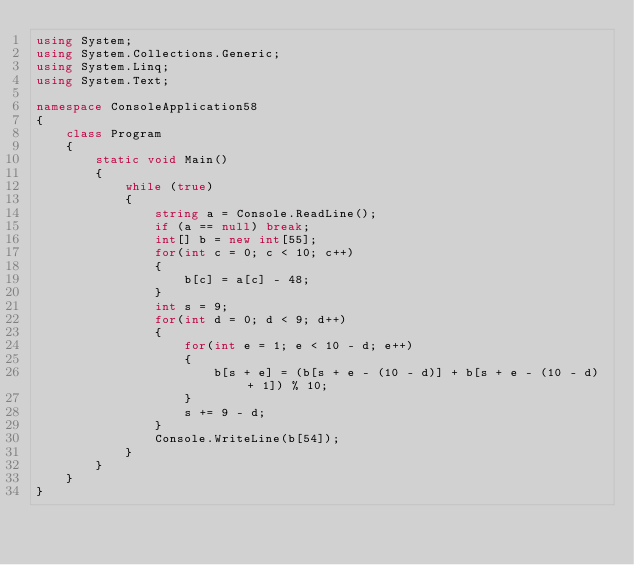<code> <loc_0><loc_0><loc_500><loc_500><_C#_>using System;
using System.Collections.Generic;
using System.Linq;
using System.Text;

namespace ConsoleApplication58
{
    class Program
    {
        static void Main()
        {
            while (true)
            {
                string a = Console.ReadLine();
                if (a == null) break;
                int[] b = new int[55];
                for(int c = 0; c < 10; c++)
                {
                    b[c] = a[c] - 48;
                }
                int s = 9;
                for(int d = 0; d < 9; d++)
                { 
                    for(int e = 1; e < 10 - d; e++)
                    {
                        b[s + e] = (b[s + e - (10 - d)] + b[s + e - (10 - d) + 1]) % 10;
                    }
                    s += 9 - d;
                }
                Console.WriteLine(b[54]);
            }
        }
    }
}</code> 